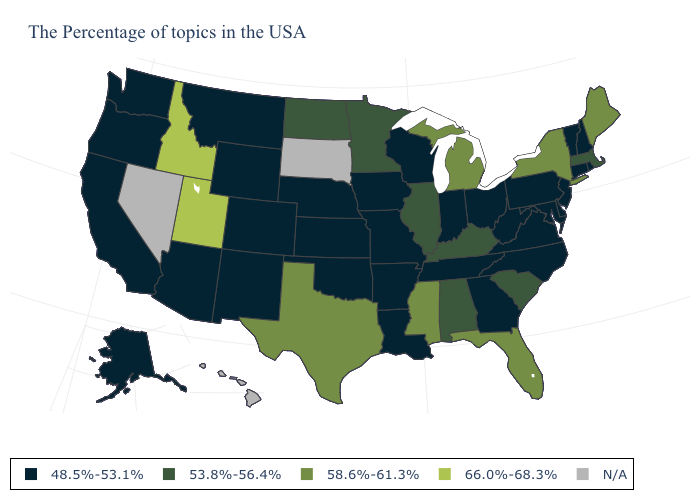How many symbols are there in the legend?
Short answer required. 5. Name the states that have a value in the range 48.5%-53.1%?
Keep it brief. Rhode Island, New Hampshire, Vermont, Connecticut, New Jersey, Delaware, Maryland, Pennsylvania, Virginia, North Carolina, West Virginia, Ohio, Georgia, Indiana, Tennessee, Wisconsin, Louisiana, Missouri, Arkansas, Iowa, Kansas, Nebraska, Oklahoma, Wyoming, Colorado, New Mexico, Montana, Arizona, California, Washington, Oregon, Alaska. What is the value of West Virginia?
Write a very short answer. 48.5%-53.1%. Does Alaska have the highest value in the West?
Answer briefly. No. How many symbols are there in the legend?
Quick response, please. 5. Does Idaho have the highest value in the USA?
Concise answer only. Yes. Name the states that have a value in the range 48.5%-53.1%?
Keep it brief. Rhode Island, New Hampshire, Vermont, Connecticut, New Jersey, Delaware, Maryland, Pennsylvania, Virginia, North Carolina, West Virginia, Ohio, Georgia, Indiana, Tennessee, Wisconsin, Louisiana, Missouri, Arkansas, Iowa, Kansas, Nebraska, Oklahoma, Wyoming, Colorado, New Mexico, Montana, Arizona, California, Washington, Oregon, Alaska. Is the legend a continuous bar?
Write a very short answer. No. Name the states that have a value in the range N/A?
Be succinct. South Dakota, Nevada, Hawaii. Name the states that have a value in the range 58.6%-61.3%?
Give a very brief answer. Maine, New York, Florida, Michigan, Mississippi, Texas. Does Michigan have the highest value in the MidWest?
Quick response, please. Yes. Among the states that border Mississippi , does Louisiana have the lowest value?
Keep it brief. Yes. Which states hav the highest value in the West?
Write a very short answer. Utah, Idaho. 